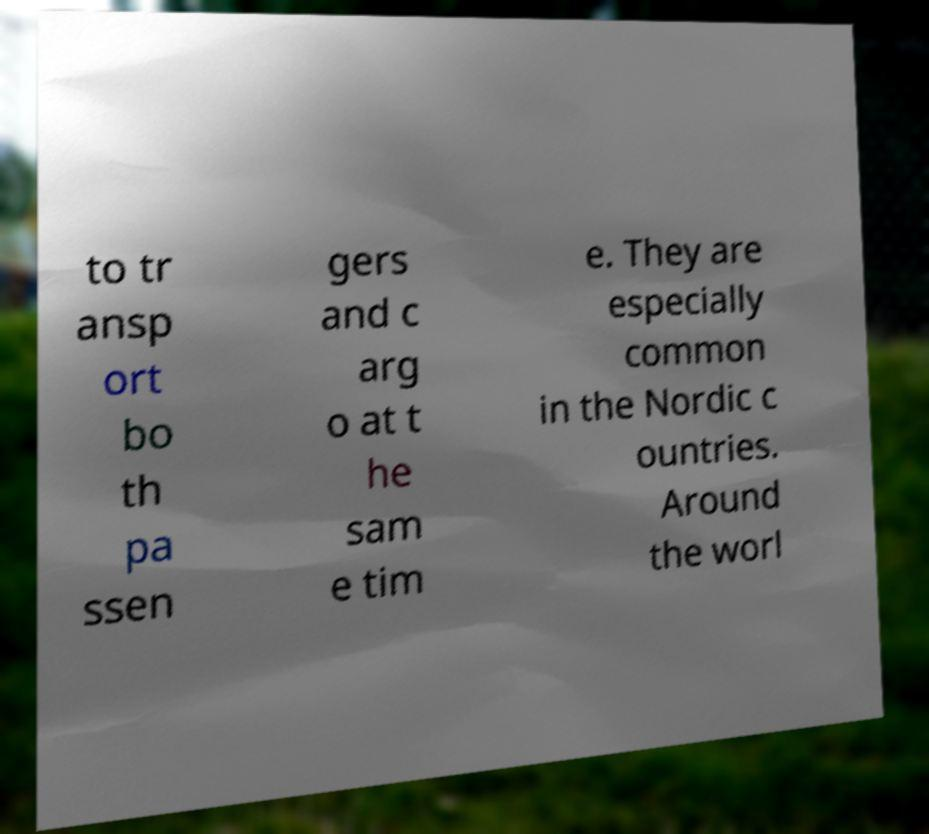There's text embedded in this image that I need extracted. Can you transcribe it verbatim? to tr ansp ort bo th pa ssen gers and c arg o at t he sam e tim e. They are especially common in the Nordic c ountries. Around the worl 